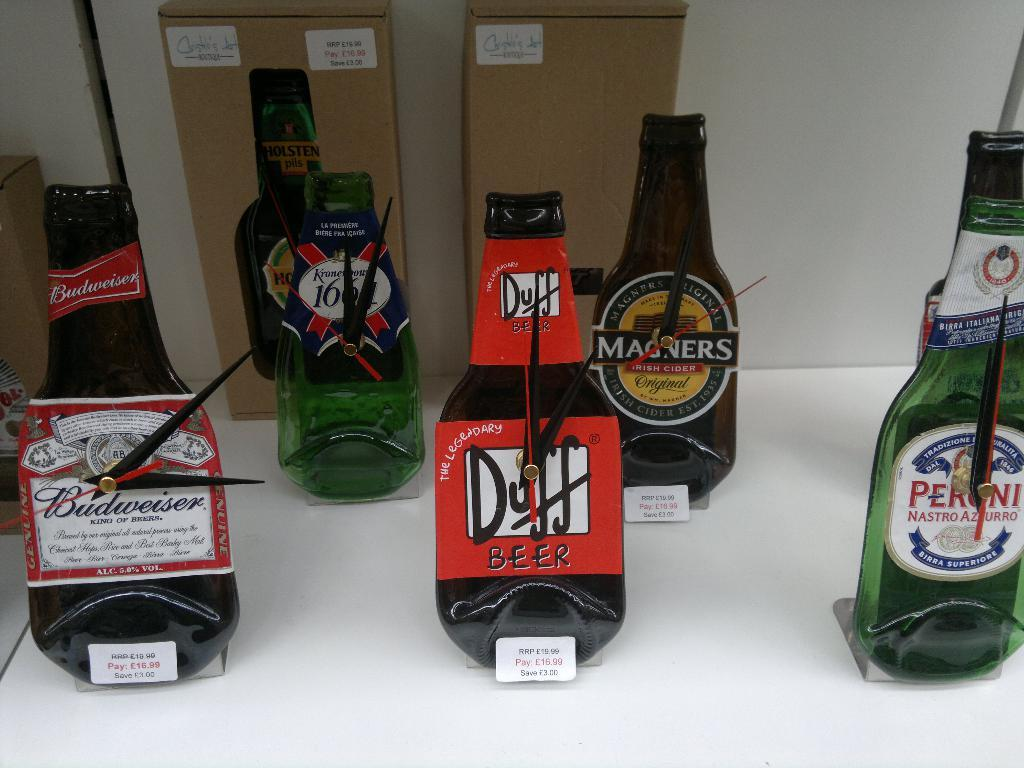<image>
Render a clear and concise summary of the photo. A can of Duff Beer is in the center of the table 